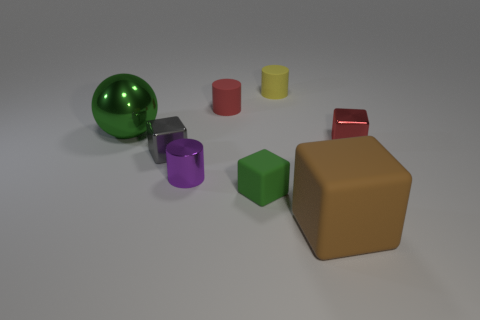Subtract all purple blocks. Subtract all blue spheres. How many blocks are left? 4 Add 2 tiny red shiny objects. How many objects exist? 10 Subtract all cylinders. How many objects are left? 5 Add 2 small metal cylinders. How many small metal cylinders are left? 3 Add 6 gray objects. How many gray objects exist? 7 Subtract 0 blue spheres. How many objects are left? 8 Subtract all small green things. Subtract all small purple metallic cylinders. How many objects are left? 6 